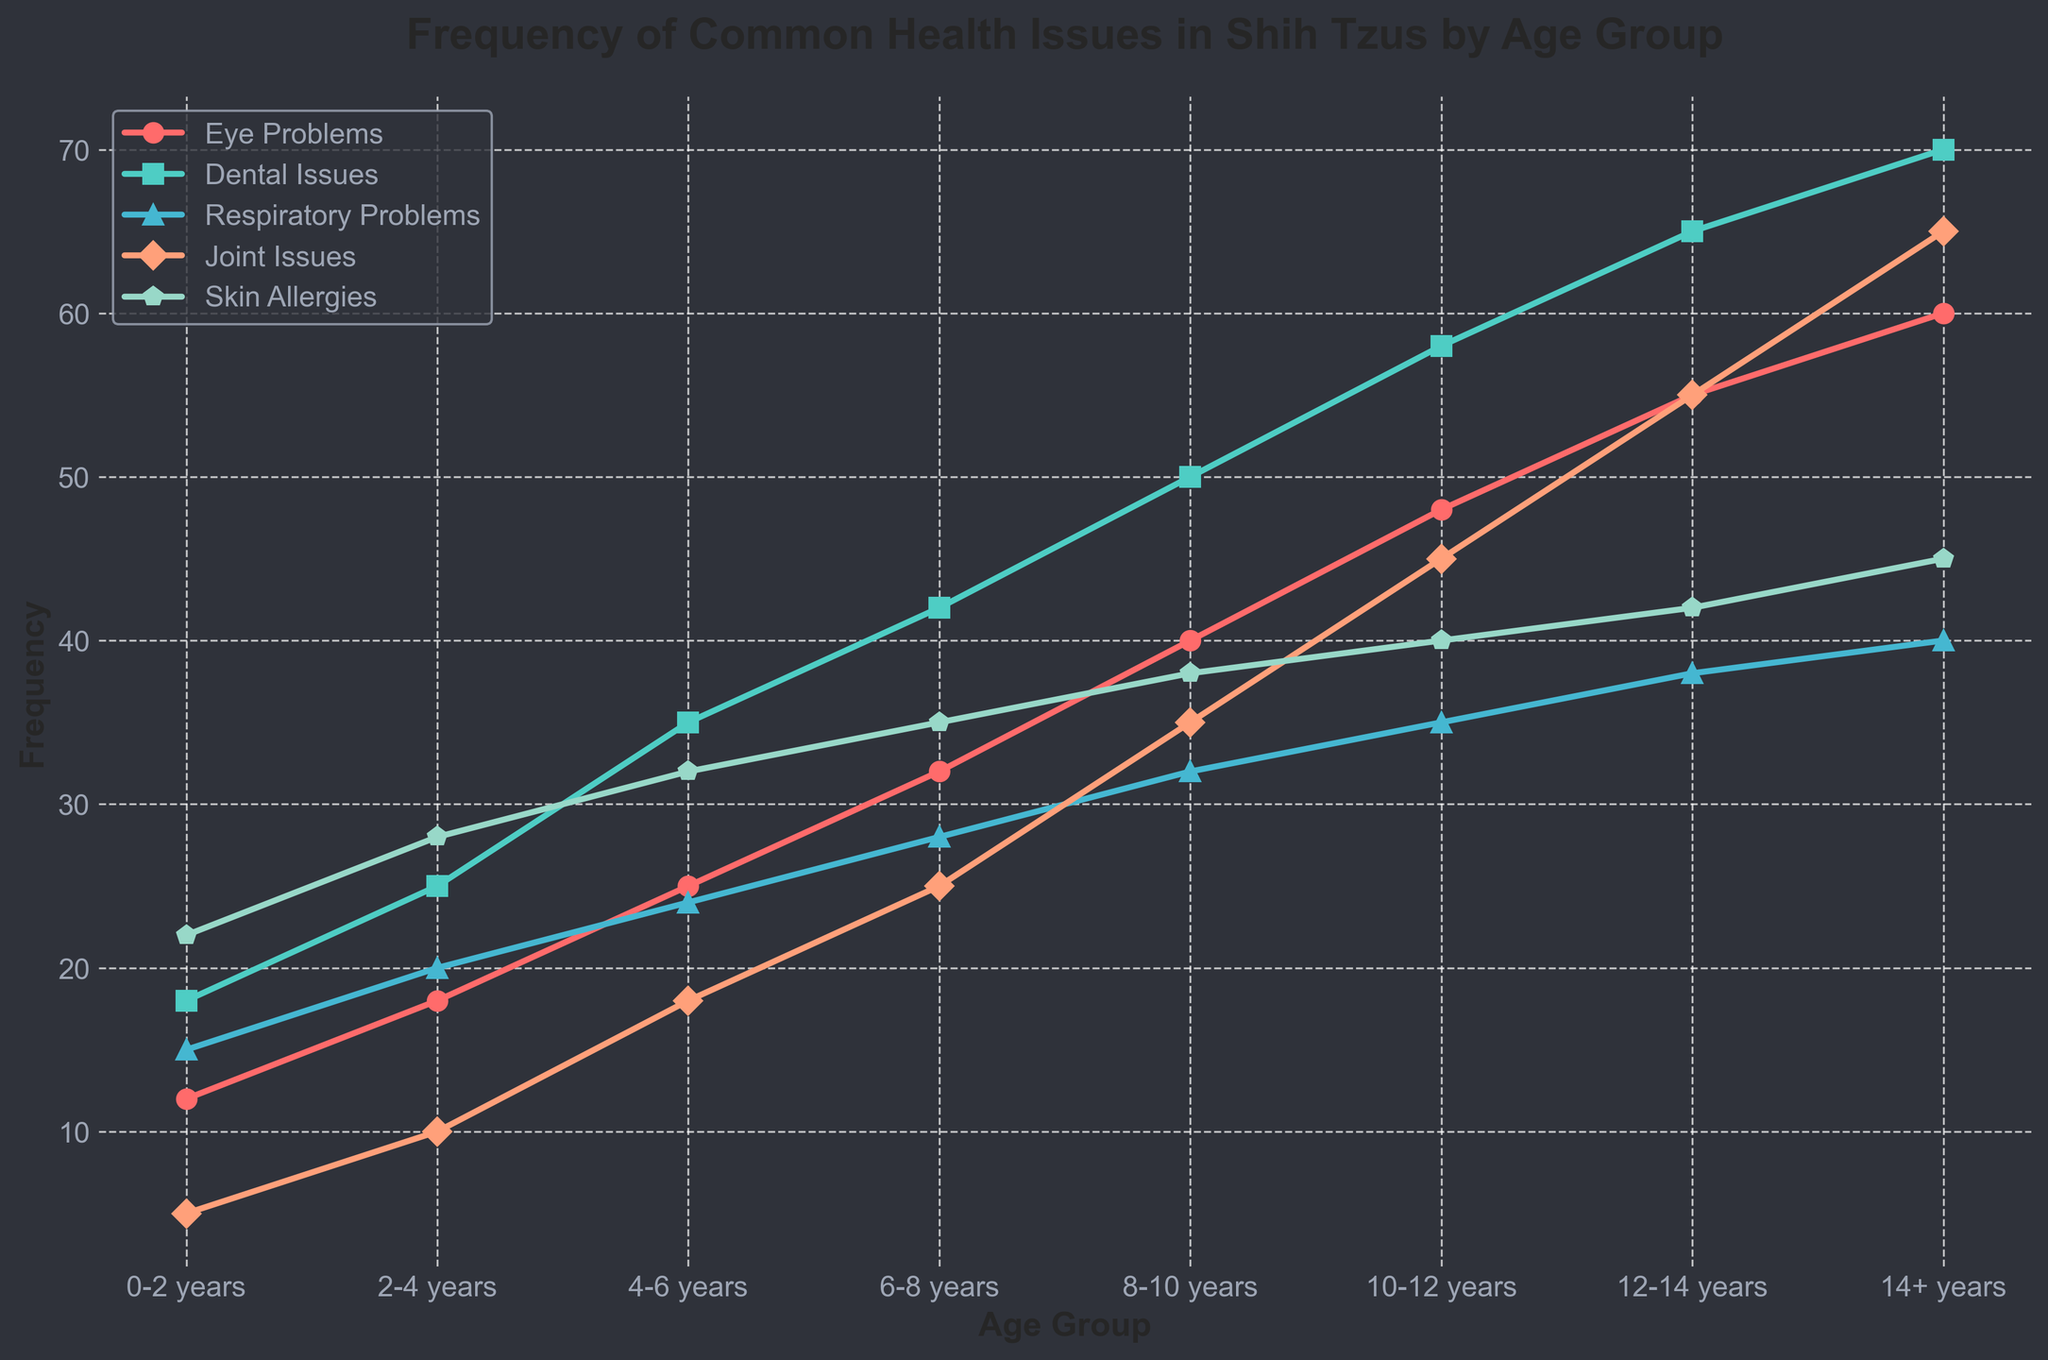what trend do you see for dental issues as the shih tzus age? as the age group increases, the frequency of dental issues steadily rises. specifically, it goes from 18 in the 0-2 years group to 70 in the 14+ years group.
Answer: increase which age group exhibits the highest frequency of respiratory problems? the 14+ years age group shows the highest frequency of respiratory problems, with a value of 40.
Answer: 14+ years if you add the frequencies of skin allergies and joint issues for the 10-12 years age group, what's the total? for the 10-12 years age group, skin allergies have a frequency of 40 and joint issues have a frequency of 45. the total is 40 + 45 = 85.
Answer: 85 how do the frequencies of eye problems and respiratory problems compare in the 8-10 years age group? in the 8-10 years age group, the frequency of eye problems is 40 while that of respiratory problems is 32. eye problems are more frequent by 8.
Answer: eye problems are more frequent which health issue shows the steepest increase in frequency from the 0-2 years group to the 14+ years group? by observing the slopes of all issues lines, joint issues show the most precipitous rise, from 5 at 0-2 years to 65 in the 14+ years group, which is the steepest compared to the other issues.
Answer: joint issues identify the age group where dental issues and skin allergies intersect or have the same frequency? there is no age group where dental issues and skin allergies have the same frequency.
Answer: none which health issue shows the smallest increase in frequency over the entire age range? respiratory problems show the smallest increase in frequency over the age range, starting at 15 in the 0-2 years group and ending at 40 in the 14+ years group, an increase of 25.
Answer: respiratory problems in which age group does the gap between respiratory problems and joint issues become the most significant? in the 14+ years age group, respiratory problems are at 40 and joint issues are at 65. the gap is 65 - 40 = 25, which is the largest among all age groups.
Answer: 14+ years compare the frequency of eye problems to skin allergies in the 2-4 years age group. which one is higher and by how much? in the 2-4 years age group, the frequency of eye problems is 18 and skin allergies are 28. hence, skin allergies are higher by 28 - 18 = 10.
Answer: skin allergies by 10 what is the overall trend for skin allergies? skin allergies generally increase as the age group progresses, starting at 22 in the 0-2 years group and reaching 45 in the 14+ years group.
Answer: increase 